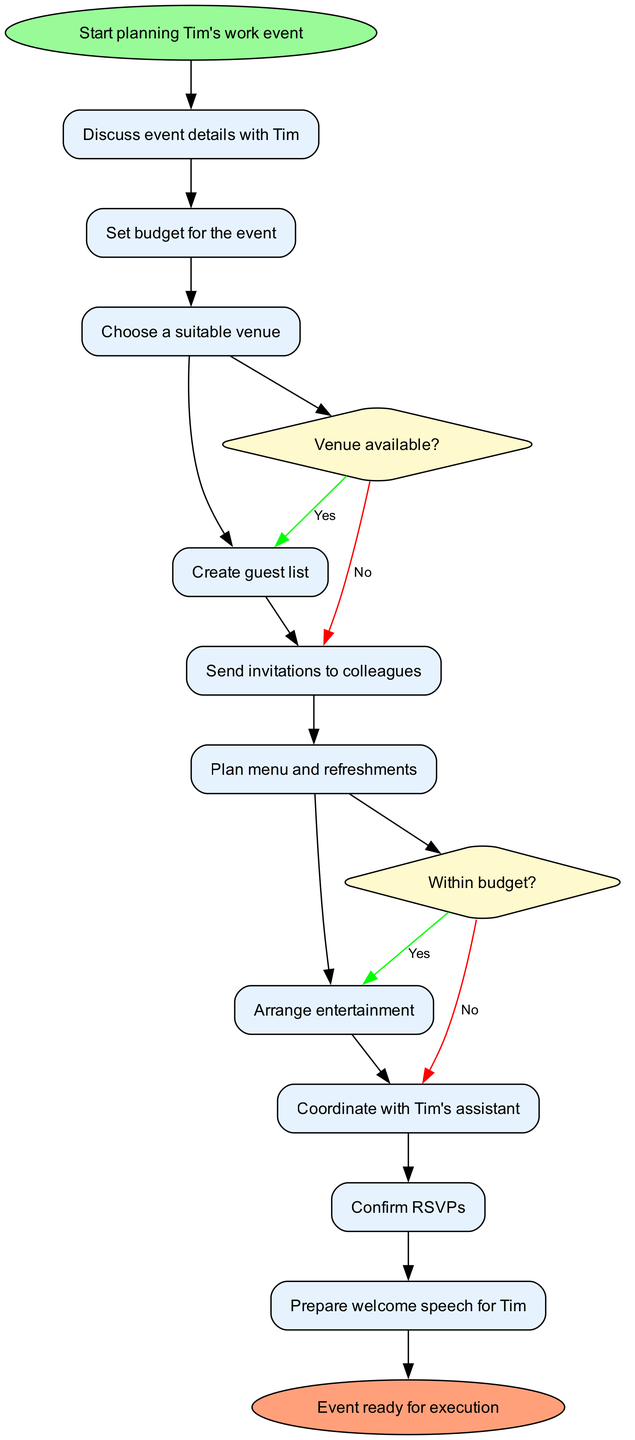What is the first activity in planning the event? The first activity shown in the diagram is directly connected to the initial node labeled "Start planning Tim's work event." This states, "Discuss event details with Tim" as the first activity following the start.
Answer: Discuss event details with Tim How many activities are there in total? To determine the total number of activities, we can count each listed activity in the activities section of the diagram. There are ten distinct activities planned for organizing the event.
Answer: 10 What decision needs to be checked after planning the venue? The decision that follows the venue planning is labeled as "Venue available?" in the diagram. This decision checks whether the selected venue can be booked.
Answer: Venue available? What happens if the venue is not available? If the venue is not available, the diagram indicates that the next action is to "Look for alternative venue." This is the option taken if the answer to the decision is 'No.'
Answer: Look for alternative venue Which activity follows the budgeting decision if it's within budget? The diagram indicates that if the planning is "Within budget," the next activity to be executed is "Choose a suitable venue." This is the direct response to the budget decision.
Answer: Choose a suitable venue What is the final step in the event planning process? The last node of the diagram indicates that after executing all the planned activities, the final step is labeled as "Event ready for execution." This shows that all prior activities culminate in readiness for the event itself.
Answer: Event ready for execution What is the relationship between sending invitations and planning the menu? "Send invitations to colleagues" comes directly before "Plan menu and refreshments" in the sequence of activities depicted in the diagram. They are connected as consecutive actions where sending invites leads into menu planning.
Answer: Consecutive actions If the budget is not met, what will be the next task? According to the decision regarding the budget, if it is determined to be "No," the next task indicated in the diagram is to "Adjust event scope." This directly follows the budget decision if it cannot be accommodated.
Answer: Adjust event scope 